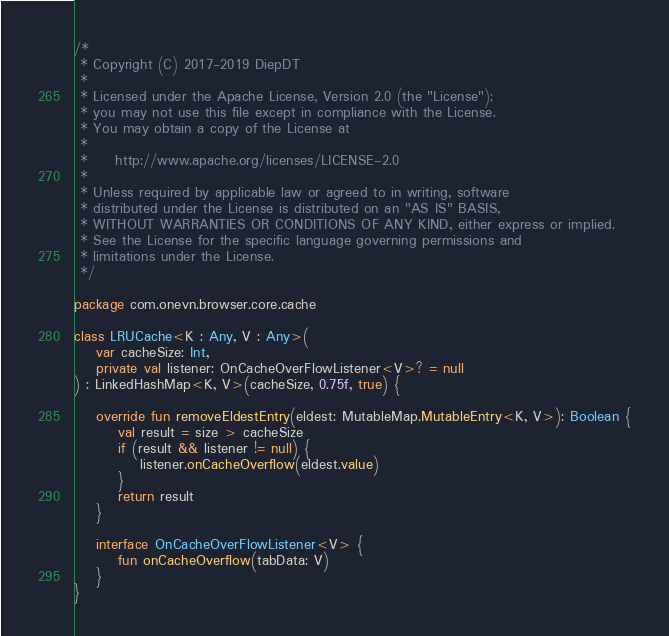Convert code to text. <code><loc_0><loc_0><loc_500><loc_500><_Kotlin_>/*
 * Copyright (C) 2017-2019 DiepDT
 *
 * Licensed under the Apache License, Version 2.0 (the "License");
 * you may not use this file except in compliance with the License.
 * You may obtain a copy of the License at
 *
 *     http://www.apache.org/licenses/LICENSE-2.0
 *
 * Unless required by applicable law or agreed to in writing, software
 * distributed under the License is distributed on an "AS IS" BASIS,
 * WITHOUT WARRANTIES OR CONDITIONS OF ANY KIND, either express or implied.
 * See the License for the specific language governing permissions and
 * limitations under the License.
 */

package com.onevn.browser.core.cache

class LRUCache<K : Any, V : Any>(
    var cacheSize: Int,
    private val listener: OnCacheOverFlowListener<V>? = null
) : LinkedHashMap<K, V>(cacheSize, 0.75f, true) {

    override fun removeEldestEntry(eldest: MutableMap.MutableEntry<K, V>): Boolean {
        val result = size > cacheSize
        if (result && listener != null) {
            listener.onCacheOverflow(eldest.value)
        }
        return result
    }

    interface OnCacheOverFlowListener<V> {
        fun onCacheOverflow(tabData: V)
    }
}
</code> 